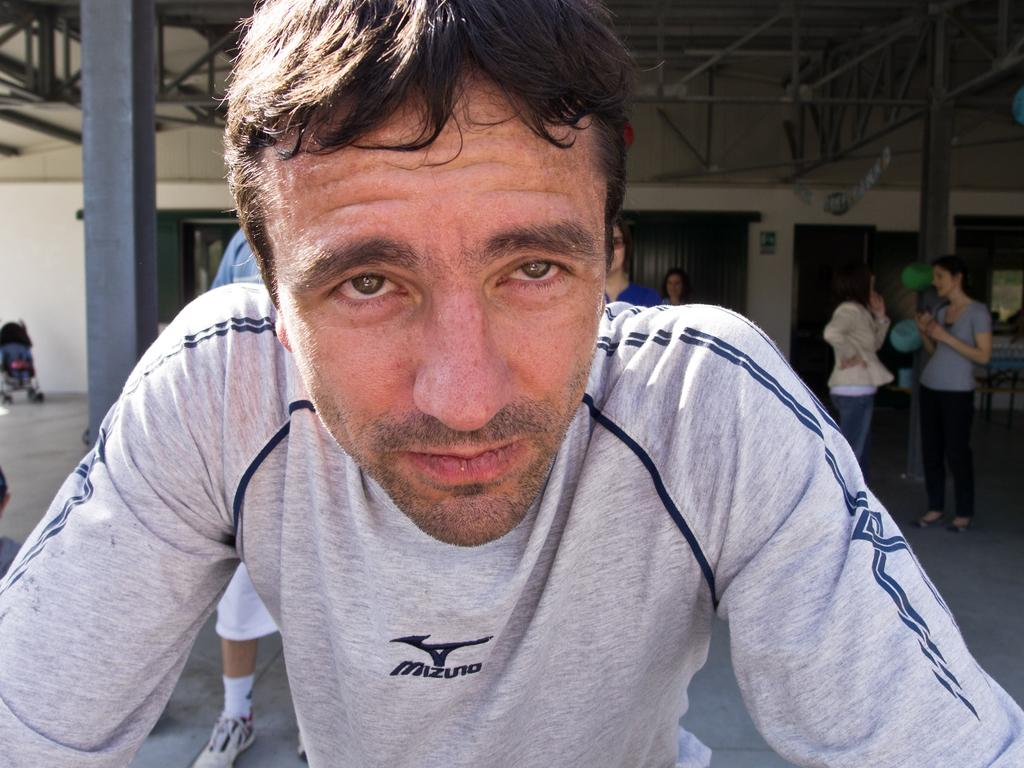What is the primary action of the person in the image? The person in the image is watching something. What can be seen in the background of the image? There are walls, pillars, balloons, a stroller, people, and objects visible in the background of the image. What architectural features are present in the background? There are pillars and walls visible in the background of the image. What additional objects are present in the background? There are balloons and a stroller visible in the background of the image. What is the nature of the objects in the background? There are people and objects visible in the background of the image. What can be seen at the top of the image? There are rods visible at the top of the image. What type of mask is the beast wearing in the image? There is no beast or mask present in the image. Can you describe the cactus in the background of the image? There is no cactus present in the image. 